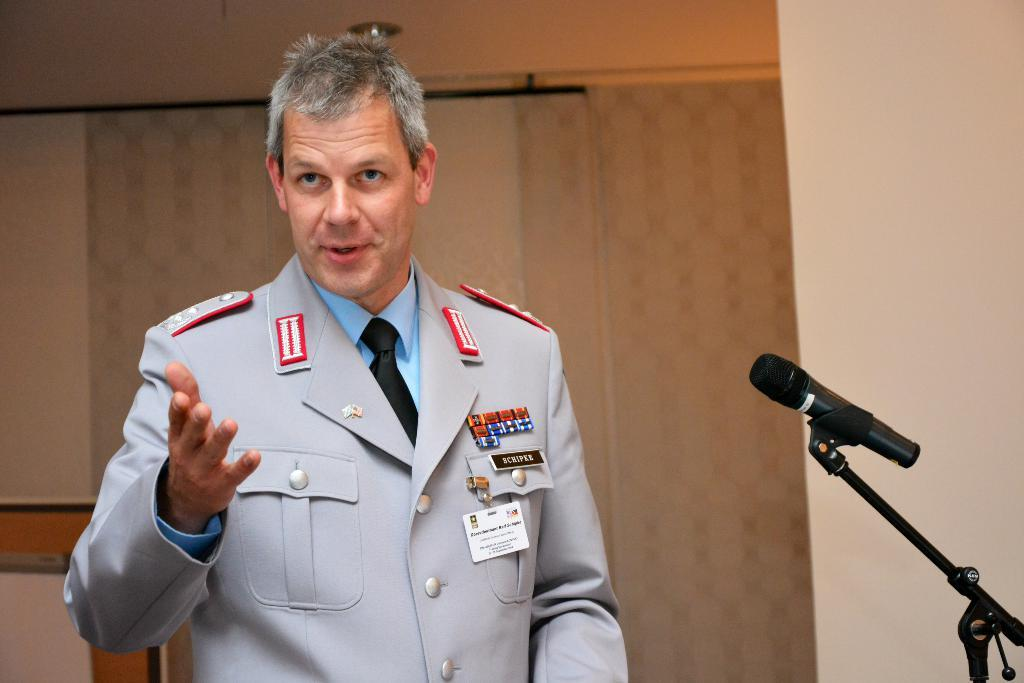Who is the main subject in the image? There is a man in the image. What is the man doing in the image? The man appears to be speaking. What object is located on the right side of the image? There is a microphone on the right side of the image. What can be seen in the background of the image? There are curtains in the background of the image. What is on the right side of the image besides the microphone? There is a wall on the right side of the image. What is the price of the plant in the image? There is no plant present in the image, so it is not possible to determine its price. 